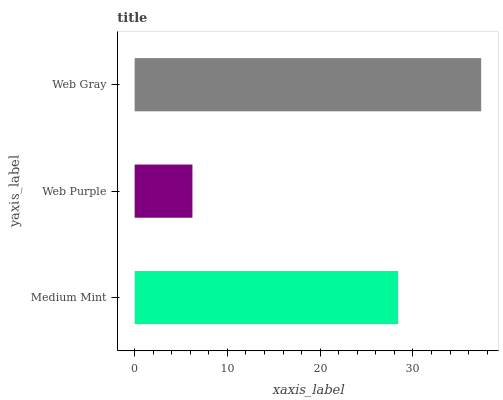Is Web Purple the minimum?
Answer yes or no. Yes. Is Web Gray the maximum?
Answer yes or no. Yes. Is Web Gray the minimum?
Answer yes or no. No. Is Web Purple the maximum?
Answer yes or no. No. Is Web Gray greater than Web Purple?
Answer yes or no. Yes. Is Web Purple less than Web Gray?
Answer yes or no. Yes. Is Web Purple greater than Web Gray?
Answer yes or no. No. Is Web Gray less than Web Purple?
Answer yes or no. No. Is Medium Mint the high median?
Answer yes or no. Yes. Is Medium Mint the low median?
Answer yes or no. Yes. Is Web Gray the high median?
Answer yes or no. No. Is Web Purple the low median?
Answer yes or no. No. 